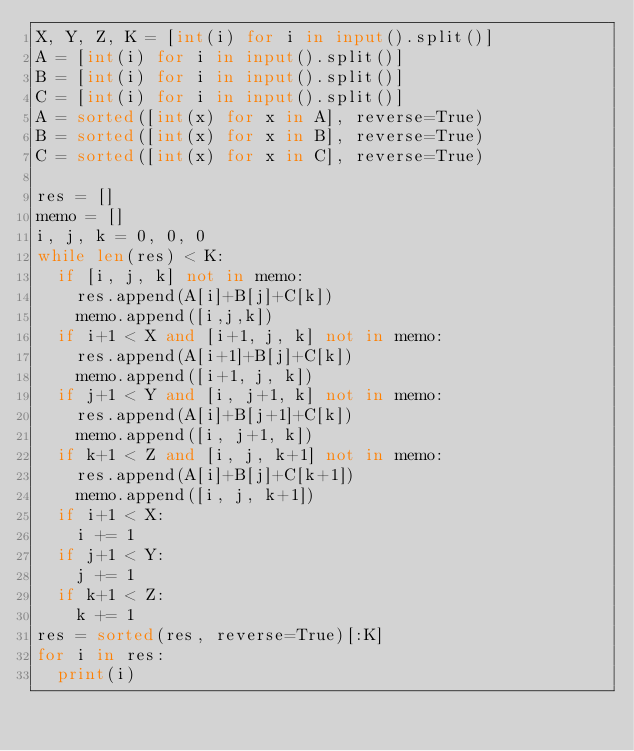<code> <loc_0><loc_0><loc_500><loc_500><_Python_>X, Y, Z, K = [int(i) for i in input().split()]
A = [int(i) for i in input().split()]
B = [int(i) for i in input().split()]
C = [int(i) for i in input().split()]
A = sorted([int(x) for x in A], reverse=True)
B = sorted([int(x) for x in B], reverse=True)
C = sorted([int(x) for x in C], reverse=True)

res = []
memo = []
i, j, k = 0, 0, 0
while len(res) < K:
  if [i, j, k] not in memo:
    res.append(A[i]+B[j]+C[k])
    memo.append([i,j,k])
  if i+1 < X and [i+1, j, k] not in memo:
    res.append(A[i+1]+B[j]+C[k])
    memo.append([i+1, j, k])
  if j+1 < Y and [i, j+1, k] not in memo:
    res.append(A[i]+B[j+1]+C[k])
    memo.append([i, j+1, k])
  if k+1 < Z and [i, j, k+1] not in memo:
    res.append(A[i]+B[j]+C[k+1])
    memo.append([i, j, k+1])
  if i+1 < X:
    i += 1
  if j+1 < Y:
    j += 1
  if k+1 < Z:
    k += 1
res = sorted(res, reverse=True)[:K]
for i in res:
  print(i)</code> 